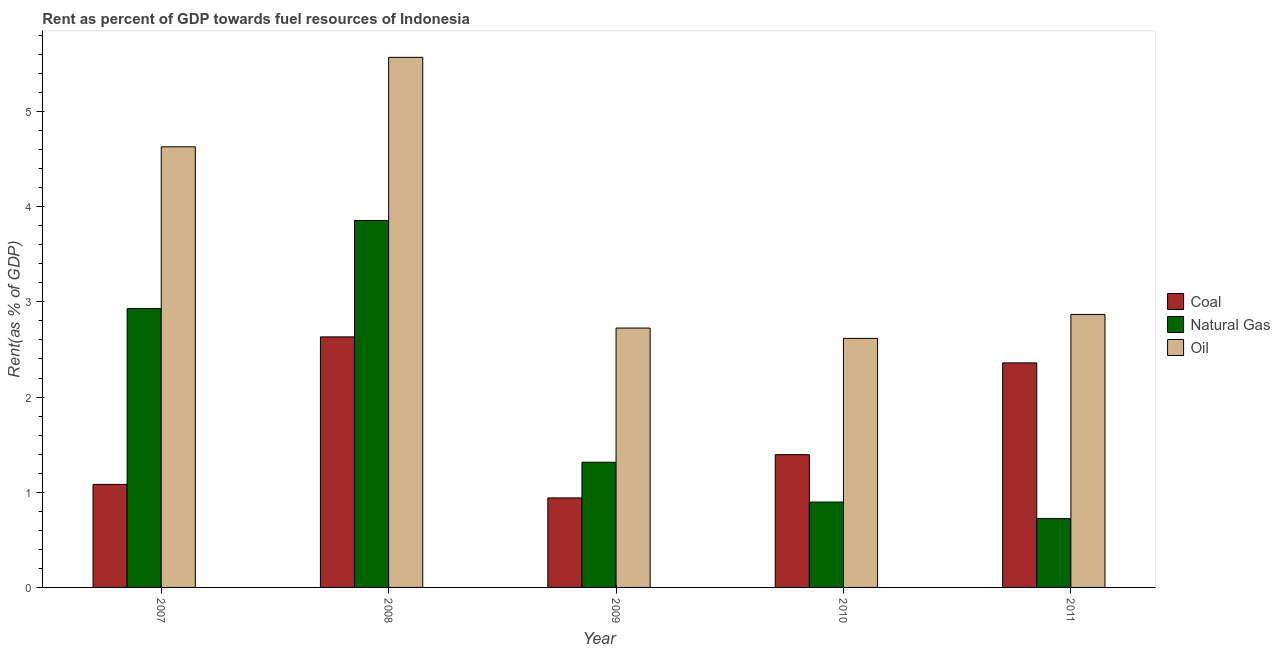How many different coloured bars are there?
Your answer should be compact. 3. How many groups of bars are there?
Your response must be concise. 5. Are the number of bars per tick equal to the number of legend labels?
Offer a very short reply. Yes. How many bars are there on the 1st tick from the left?
Offer a very short reply. 3. What is the rent towards oil in 2010?
Ensure brevity in your answer.  2.62. Across all years, what is the maximum rent towards natural gas?
Your answer should be compact. 3.85. Across all years, what is the minimum rent towards oil?
Keep it short and to the point. 2.62. What is the total rent towards natural gas in the graph?
Provide a short and direct response. 9.72. What is the difference between the rent towards coal in 2010 and that in 2011?
Offer a terse response. -0.96. What is the difference between the rent towards oil in 2008 and the rent towards natural gas in 2009?
Your response must be concise. 2.84. What is the average rent towards natural gas per year?
Your response must be concise. 1.94. In the year 2011, what is the difference between the rent towards coal and rent towards oil?
Provide a short and direct response. 0. What is the ratio of the rent towards oil in 2008 to that in 2011?
Your response must be concise. 1.94. Is the rent towards oil in 2008 less than that in 2010?
Give a very brief answer. No. What is the difference between the highest and the second highest rent towards natural gas?
Provide a succinct answer. 0.93. What is the difference between the highest and the lowest rent towards oil?
Offer a terse response. 2.95. In how many years, is the rent towards natural gas greater than the average rent towards natural gas taken over all years?
Keep it short and to the point. 2. What does the 1st bar from the left in 2008 represents?
Provide a short and direct response. Coal. What does the 2nd bar from the right in 2008 represents?
Your response must be concise. Natural Gas. How many years are there in the graph?
Ensure brevity in your answer.  5. What is the difference between two consecutive major ticks on the Y-axis?
Ensure brevity in your answer.  1. Does the graph contain any zero values?
Ensure brevity in your answer.  No. Does the graph contain grids?
Ensure brevity in your answer.  No. Where does the legend appear in the graph?
Give a very brief answer. Center right. How many legend labels are there?
Your response must be concise. 3. What is the title of the graph?
Offer a terse response. Rent as percent of GDP towards fuel resources of Indonesia. Does "Liquid fuel" appear as one of the legend labels in the graph?
Make the answer very short. No. What is the label or title of the Y-axis?
Keep it short and to the point. Rent(as % of GDP). What is the Rent(as % of GDP) of Coal in 2007?
Your answer should be compact. 1.08. What is the Rent(as % of GDP) of Natural Gas in 2007?
Offer a very short reply. 2.93. What is the Rent(as % of GDP) of Oil in 2007?
Your response must be concise. 4.63. What is the Rent(as % of GDP) in Coal in 2008?
Your response must be concise. 2.63. What is the Rent(as % of GDP) in Natural Gas in 2008?
Provide a short and direct response. 3.85. What is the Rent(as % of GDP) of Oil in 2008?
Provide a short and direct response. 5.57. What is the Rent(as % of GDP) in Coal in 2009?
Your answer should be compact. 0.94. What is the Rent(as % of GDP) in Natural Gas in 2009?
Offer a very short reply. 1.32. What is the Rent(as % of GDP) in Oil in 2009?
Your answer should be very brief. 2.72. What is the Rent(as % of GDP) of Coal in 2010?
Offer a very short reply. 1.39. What is the Rent(as % of GDP) of Natural Gas in 2010?
Offer a very short reply. 0.9. What is the Rent(as % of GDP) of Oil in 2010?
Make the answer very short. 2.62. What is the Rent(as % of GDP) in Coal in 2011?
Your answer should be compact. 2.36. What is the Rent(as % of GDP) of Natural Gas in 2011?
Keep it short and to the point. 0.72. What is the Rent(as % of GDP) of Oil in 2011?
Your answer should be very brief. 2.87. Across all years, what is the maximum Rent(as % of GDP) of Coal?
Provide a short and direct response. 2.63. Across all years, what is the maximum Rent(as % of GDP) in Natural Gas?
Your response must be concise. 3.85. Across all years, what is the maximum Rent(as % of GDP) in Oil?
Make the answer very short. 5.57. Across all years, what is the minimum Rent(as % of GDP) of Coal?
Ensure brevity in your answer.  0.94. Across all years, what is the minimum Rent(as % of GDP) in Natural Gas?
Offer a terse response. 0.72. Across all years, what is the minimum Rent(as % of GDP) in Oil?
Ensure brevity in your answer.  2.62. What is the total Rent(as % of GDP) in Coal in the graph?
Provide a short and direct response. 8.41. What is the total Rent(as % of GDP) in Natural Gas in the graph?
Ensure brevity in your answer.  9.72. What is the total Rent(as % of GDP) of Oil in the graph?
Your answer should be compact. 18.41. What is the difference between the Rent(as % of GDP) in Coal in 2007 and that in 2008?
Your answer should be compact. -1.55. What is the difference between the Rent(as % of GDP) in Natural Gas in 2007 and that in 2008?
Provide a succinct answer. -0.93. What is the difference between the Rent(as % of GDP) of Oil in 2007 and that in 2008?
Provide a succinct answer. -0.94. What is the difference between the Rent(as % of GDP) in Coal in 2007 and that in 2009?
Keep it short and to the point. 0.14. What is the difference between the Rent(as % of GDP) of Natural Gas in 2007 and that in 2009?
Give a very brief answer. 1.61. What is the difference between the Rent(as % of GDP) of Oil in 2007 and that in 2009?
Ensure brevity in your answer.  1.9. What is the difference between the Rent(as % of GDP) of Coal in 2007 and that in 2010?
Offer a very short reply. -0.31. What is the difference between the Rent(as % of GDP) of Natural Gas in 2007 and that in 2010?
Your answer should be compact. 2.03. What is the difference between the Rent(as % of GDP) in Oil in 2007 and that in 2010?
Your answer should be very brief. 2.01. What is the difference between the Rent(as % of GDP) in Coal in 2007 and that in 2011?
Ensure brevity in your answer.  -1.28. What is the difference between the Rent(as % of GDP) of Natural Gas in 2007 and that in 2011?
Your answer should be compact. 2.21. What is the difference between the Rent(as % of GDP) of Oil in 2007 and that in 2011?
Give a very brief answer. 1.76. What is the difference between the Rent(as % of GDP) in Coal in 2008 and that in 2009?
Make the answer very short. 1.69. What is the difference between the Rent(as % of GDP) in Natural Gas in 2008 and that in 2009?
Provide a succinct answer. 2.54. What is the difference between the Rent(as % of GDP) of Oil in 2008 and that in 2009?
Your response must be concise. 2.84. What is the difference between the Rent(as % of GDP) in Coal in 2008 and that in 2010?
Your answer should be very brief. 1.24. What is the difference between the Rent(as % of GDP) of Natural Gas in 2008 and that in 2010?
Keep it short and to the point. 2.96. What is the difference between the Rent(as % of GDP) of Oil in 2008 and that in 2010?
Provide a succinct answer. 2.95. What is the difference between the Rent(as % of GDP) in Coal in 2008 and that in 2011?
Provide a short and direct response. 0.27. What is the difference between the Rent(as % of GDP) of Natural Gas in 2008 and that in 2011?
Ensure brevity in your answer.  3.13. What is the difference between the Rent(as % of GDP) of Oil in 2008 and that in 2011?
Offer a terse response. 2.7. What is the difference between the Rent(as % of GDP) of Coal in 2009 and that in 2010?
Your answer should be compact. -0.45. What is the difference between the Rent(as % of GDP) of Natural Gas in 2009 and that in 2010?
Your answer should be very brief. 0.42. What is the difference between the Rent(as % of GDP) in Oil in 2009 and that in 2010?
Provide a short and direct response. 0.11. What is the difference between the Rent(as % of GDP) in Coal in 2009 and that in 2011?
Provide a succinct answer. -1.42. What is the difference between the Rent(as % of GDP) of Natural Gas in 2009 and that in 2011?
Give a very brief answer. 0.59. What is the difference between the Rent(as % of GDP) in Oil in 2009 and that in 2011?
Give a very brief answer. -0.14. What is the difference between the Rent(as % of GDP) in Coal in 2010 and that in 2011?
Provide a short and direct response. -0.96. What is the difference between the Rent(as % of GDP) in Natural Gas in 2010 and that in 2011?
Keep it short and to the point. 0.17. What is the difference between the Rent(as % of GDP) in Oil in 2010 and that in 2011?
Ensure brevity in your answer.  -0.25. What is the difference between the Rent(as % of GDP) in Coal in 2007 and the Rent(as % of GDP) in Natural Gas in 2008?
Your response must be concise. -2.77. What is the difference between the Rent(as % of GDP) of Coal in 2007 and the Rent(as % of GDP) of Oil in 2008?
Offer a very short reply. -4.49. What is the difference between the Rent(as % of GDP) in Natural Gas in 2007 and the Rent(as % of GDP) in Oil in 2008?
Make the answer very short. -2.64. What is the difference between the Rent(as % of GDP) of Coal in 2007 and the Rent(as % of GDP) of Natural Gas in 2009?
Your answer should be very brief. -0.23. What is the difference between the Rent(as % of GDP) in Coal in 2007 and the Rent(as % of GDP) in Oil in 2009?
Provide a succinct answer. -1.64. What is the difference between the Rent(as % of GDP) in Natural Gas in 2007 and the Rent(as % of GDP) in Oil in 2009?
Your response must be concise. 0.2. What is the difference between the Rent(as % of GDP) of Coal in 2007 and the Rent(as % of GDP) of Natural Gas in 2010?
Offer a terse response. 0.19. What is the difference between the Rent(as % of GDP) of Coal in 2007 and the Rent(as % of GDP) of Oil in 2010?
Your answer should be compact. -1.53. What is the difference between the Rent(as % of GDP) in Natural Gas in 2007 and the Rent(as % of GDP) in Oil in 2010?
Make the answer very short. 0.31. What is the difference between the Rent(as % of GDP) in Coal in 2007 and the Rent(as % of GDP) in Natural Gas in 2011?
Offer a terse response. 0.36. What is the difference between the Rent(as % of GDP) in Coal in 2007 and the Rent(as % of GDP) in Oil in 2011?
Offer a terse response. -1.79. What is the difference between the Rent(as % of GDP) in Natural Gas in 2007 and the Rent(as % of GDP) in Oil in 2011?
Your answer should be compact. 0.06. What is the difference between the Rent(as % of GDP) of Coal in 2008 and the Rent(as % of GDP) of Natural Gas in 2009?
Your answer should be very brief. 1.32. What is the difference between the Rent(as % of GDP) of Coal in 2008 and the Rent(as % of GDP) of Oil in 2009?
Make the answer very short. -0.09. What is the difference between the Rent(as % of GDP) in Natural Gas in 2008 and the Rent(as % of GDP) in Oil in 2009?
Keep it short and to the point. 1.13. What is the difference between the Rent(as % of GDP) in Coal in 2008 and the Rent(as % of GDP) in Natural Gas in 2010?
Provide a short and direct response. 1.74. What is the difference between the Rent(as % of GDP) of Coal in 2008 and the Rent(as % of GDP) of Oil in 2010?
Your response must be concise. 0.02. What is the difference between the Rent(as % of GDP) of Natural Gas in 2008 and the Rent(as % of GDP) of Oil in 2010?
Your response must be concise. 1.24. What is the difference between the Rent(as % of GDP) of Coal in 2008 and the Rent(as % of GDP) of Natural Gas in 2011?
Provide a short and direct response. 1.91. What is the difference between the Rent(as % of GDP) in Coal in 2008 and the Rent(as % of GDP) in Oil in 2011?
Your answer should be very brief. -0.24. What is the difference between the Rent(as % of GDP) in Natural Gas in 2008 and the Rent(as % of GDP) in Oil in 2011?
Make the answer very short. 0.99. What is the difference between the Rent(as % of GDP) of Coal in 2009 and the Rent(as % of GDP) of Natural Gas in 2010?
Offer a very short reply. 0.04. What is the difference between the Rent(as % of GDP) of Coal in 2009 and the Rent(as % of GDP) of Oil in 2010?
Provide a succinct answer. -1.68. What is the difference between the Rent(as % of GDP) in Natural Gas in 2009 and the Rent(as % of GDP) in Oil in 2010?
Your answer should be compact. -1.3. What is the difference between the Rent(as % of GDP) in Coal in 2009 and the Rent(as % of GDP) in Natural Gas in 2011?
Make the answer very short. 0.22. What is the difference between the Rent(as % of GDP) in Coal in 2009 and the Rent(as % of GDP) in Oil in 2011?
Your answer should be compact. -1.93. What is the difference between the Rent(as % of GDP) of Natural Gas in 2009 and the Rent(as % of GDP) of Oil in 2011?
Provide a short and direct response. -1.55. What is the difference between the Rent(as % of GDP) of Coal in 2010 and the Rent(as % of GDP) of Natural Gas in 2011?
Your answer should be very brief. 0.67. What is the difference between the Rent(as % of GDP) of Coal in 2010 and the Rent(as % of GDP) of Oil in 2011?
Offer a terse response. -1.47. What is the difference between the Rent(as % of GDP) in Natural Gas in 2010 and the Rent(as % of GDP) in Oil in 2011?
Offer a terse response. -1.97. What is the average Rent(as % of GDP) of Coal per year?
Offer a very short reply. 1.68. What is the average Rent(as % of GDP) in Natural Gas per year?
Keep it short and to the point. 1.94. What is the average Rent(as % of GDP) of Oil per year?
Keep it short and to the point. 3.68. In the year 2007, what is the difference between the Rent(as % of GDP) in Coal and Rent(as % of GDP) in Natural Gas?
Your answer should be compact. -1.85. In the year 2007, what is the difference between the Rent(as % of GDP) of Coal and Rent(as % of GDP) of Oil?
Your answer should be very brief. -3.55. In the year 2007, what is the difference between the Rent(as % of GDP) of Natural Gas and Rent(as % of GDP) of Oil?
Provide a short and direct response. -1.7. In the year 2008, what is the difference between the Rent(as % of GDP) of Coal and Rent(as % of GDP) of Natural Gas?
Give a very brief answer. -1.22. In the year 2008, what is the difference between the Rent(as % of GDP) in Coal and Rent(as % of GDP) in Oil?
Offer a terse response. -2.94. In the year 2008, what is the difference between the Rent(as % of GDP) of Natural Gas and Rent(as % of GDP) of Oil?
Give a very brief answer. -1.71. In the year 2009, what is the difference between the Rent(as % of GDP) in Coal and Rent(as % of GDP) in Natural Gas?
Your answer should be compact. -0.37. In the year 2009, what is the difference between the Rent(as % of GDP) in Coal and Rent(as % of GDP) in Oil?
Your answer should be compact. -1.78. In the year 2009, what is the difference between the Rent(as % of GDP) of Natural Gas and Rent(as % of GDP) of Oil?
Ensure brevity in your answer.  -1.41. In the year 2010, what is the difference between the Rent(as % of GDP) in Coal and Rent(as % of GDP) in Natural Gas?
Your answer should be very brief. 0.5. In the year 2010, what is the difference between the Rent(as % of GDP) in Coal and Rent(as % of GDP) in Oil?
Provide a short and direct response. -1.22. In the year 2010, what is the difference between the Rent(as % of GDP) in Natural Gas and Rent(as % of GDP) in Oil?
Give a very brief answer. -1.72. In the year 2011, what is the difference between the Rent(as % of GDP) in Coal and Rent(as % of GDP) in Natural Gas?
Your response must be concise. 1.64. In the year 2011, what is the difference between the Rent(as % of GDP) in Coal and Rent(as % of GDP) in Oil?
Make the answer very short. -0.51. In the year 2011, what is the difference between the Rent(as % of GDP) in Natural Gas and Rent(as % of GDP) in Oil?
Your response must be concise. -2.15. What is the ratio of the Rent(as % of GDP) in Coal in 2007 to that in 2008?
Provide a short and direct response. 0.41. What is the ratio of the Rent(as % of GDP) in Natural Gas in 2007 to that in 2008?
Give a very brief answer. 0.76. What is the ratio of the Rent(as % of GDP) in Oil in 2007 to that in 2008?
Provide a short and direct response. 0.83. What is the ratio of the Rent(as % of GDP) in Coal in 2007 to that in 2009?
Provide a succinct answer. 1.15. What is the ratio of the Rent(as % of GDP) in Natural Gas in 2007 to that in 2009?
Ensure brevity in your answer.  2.23. What is the ratio of the Rent(as % of GDP) of Oil in 2007 to that in 2009?
Your response must be concise. 1.7. What is the ratio of the Rent(as % of GDP) in Coal in 2007 to that in 2010?
Provide a succinct answer. 0.78. What is the ratio of the Rent(as % of GDP) of Natural Gas in 2007 to that in 2010?
Your answer should be very brief. 3.27. What is the ratio of the Rent(as % of GDP) of Oil in 2007 to that in 2010?
Offer a very short reply. 1.77. What is the ratio of the Rent(as % of GDP) in Coal in 2007 to that in 2011?
Offer a very short reply. 0.46. What is the ratio of the Rent(as % of GDP) in Natural Gas in 2007 to that in 2011?
Provide a succinct answer. 4.05. What is the ratio of the Rent(as % of GDP) in Oil in 2007 to that in 2011?
Offer a very short reply. 1.61. What is the ratio of the Rent(as % of GDP) of Coal in 2008 to that in 2009?
Provide a succinct answer. 2.8. What is the ratio of the Rent(as % of GDP) of Natural Gas in 2008 to that in 2009?
Give a very brief answer. 2.93. What is the ratio of the Rent(as % of GDP) in Oil in 2008 to that in 2009?
Your response must be concise. 2.04. What is the ratio of the Rent(as % of GDP) of Coal in 2008 to that in 2010?
Offer a very short reply. 1.89. What is the ratio of the Rent(as % of GDP) in Natural Gas in 2008 to that in 2010?
Ensure brevity in your answer.  4.3. What is the ratio of the Rent(as % of GDP) in Oil in 2008 to that in 2010?
Offer a very short reply. 2.13. What is the ratio of the Rent(as % of GDP) of Coal in 2008 to that in 2011?
Your answer should be compact. 1.12. What is the ratio of the Rent(as % of GDP) of Natural Gas in 2008 to that in 2011?
Your answer should be very brief. 5.33. What is the ratio of the Rent(as % of GDP) in Oil in 2008 to that in 2011?
Make the answer very short. 1.94. What is the ratio of the Rent(as % of GDP) of Coal in 2009 to that in 2010?
Offer a very short reply. 0.67. What is the ratio of the Rent(as % of GDP) in Natural Gas in 2009 to that in 2010?
Your response must be concise. 1.47. What is the ratio of the Rent(as % of GDP) of Oil in 2009 to that in 2010?
Give a very brief answer. 1.04. What is the ratio of the Rent(as % of GDP) of Coal in 2009 to that in 2011?
Your answer should be compact. 0.4. What is the ratio of the Rent(as % of GDP) in Natural Gas in 2009 to that in 2011?
Your response must be concise. 1.82. What is the ratio of the Rent(as % of GDP) of Coal in 2010 to that in 2011?
Make the answer very short. 0.59. What is the ratio of the Rent(as % of GDP) of Natural Gas in 2010 to that in 2011?
Give a very brief answer. 1.24. What is the ratio of the Rent(as % of GDP) of Oil in 2010 to that in 2011?
Your response must be concise. 0.91. What is the difference between the highest and the second highest Rent(as % of GDP) of Coal?
Keep it short and to the point. 0.27. What is the difference between the highest and the second highest Rent(as % of GDP) in Natural Gas?
Your answer should be very brief. 0.93. What is the difference between the highest and the second highest Rent(as % of GDP) in Oil?
Keep it short and to the point. 0.94. What is the difference between the highest and the lowest Rent(as % of GDP) in Coal?
Ensure brevity in your answer.  1.69. What is the difference between the highest and the lowest Rent(as % of GDP) of Natural Gas?
Keep it short and to the point. 3.13. What is the difference between the highest and the lowest Rent(as % of GDP) of Oil?
Ensure brevity in your answer.  2.95. 